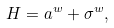<formula> <loc_0><loc_0><loc_500><loc_500>H = a ^ { w } + \sigma ^ { w } ,</formula> 